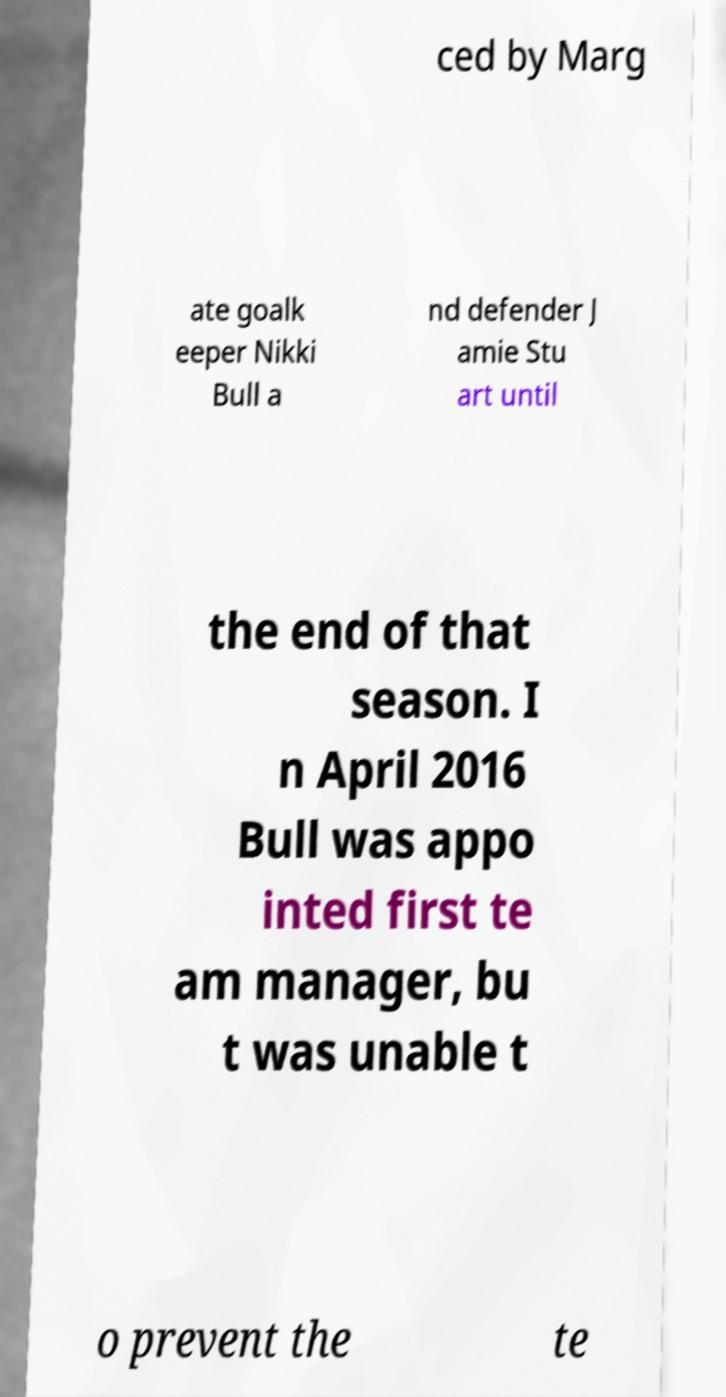There's text embedded in this image that I need extracted. Can you transcribe it verbatim? ced by Marg ate goalk eeper Nikki Bull a nd defender J amie Stu art until the end of that season. I n April 2016 Bull was appo inted first te am manager, bu t was unable t o prevent the te 